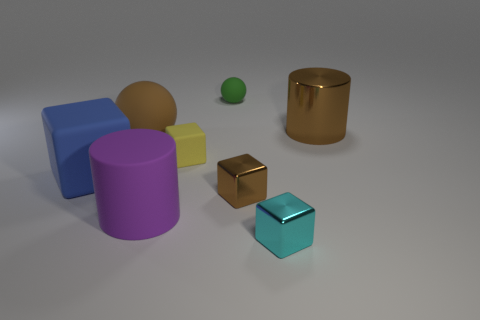The big thing that is the same color as the big ball is what shape?
Give a very brief answer. Cylinder. Is the shape of the small green object the same as the large matte thing behind the big matte cube?
Offer a terse response. Yes. There is a matte thing that is in front of the blue block; is its shape the same as the big shiny object?
Offer a terse response. Yes. There is another small rubber object that is the same shape as the brown rubber thing; what is its color?
Offer a very short reply. Green. Are there the same number of purple objects that are to the right of the large brown metallic cylinder and large cyan metal balls?
Provide a succinct answer. Yes. How many small objects are both in front of the green object and on the right side of the small yellow matte object?
Provide a succinct answer. 2. What is the size of the blue matte object that is the same shape as the tiny cyan object?
Provide a short and direct response. Large. What number of big blue cubes are made of the same material as the blue object?
Your answer should be compact. 0. Is the number of small cyan metallic things behind the large purple thing less than the number of tiny brown metallic things?
Ensure brevity in your answer.  Yes. What number of tiny yellow matte spheres are there?
Ensure brevity in your answer.  0. 